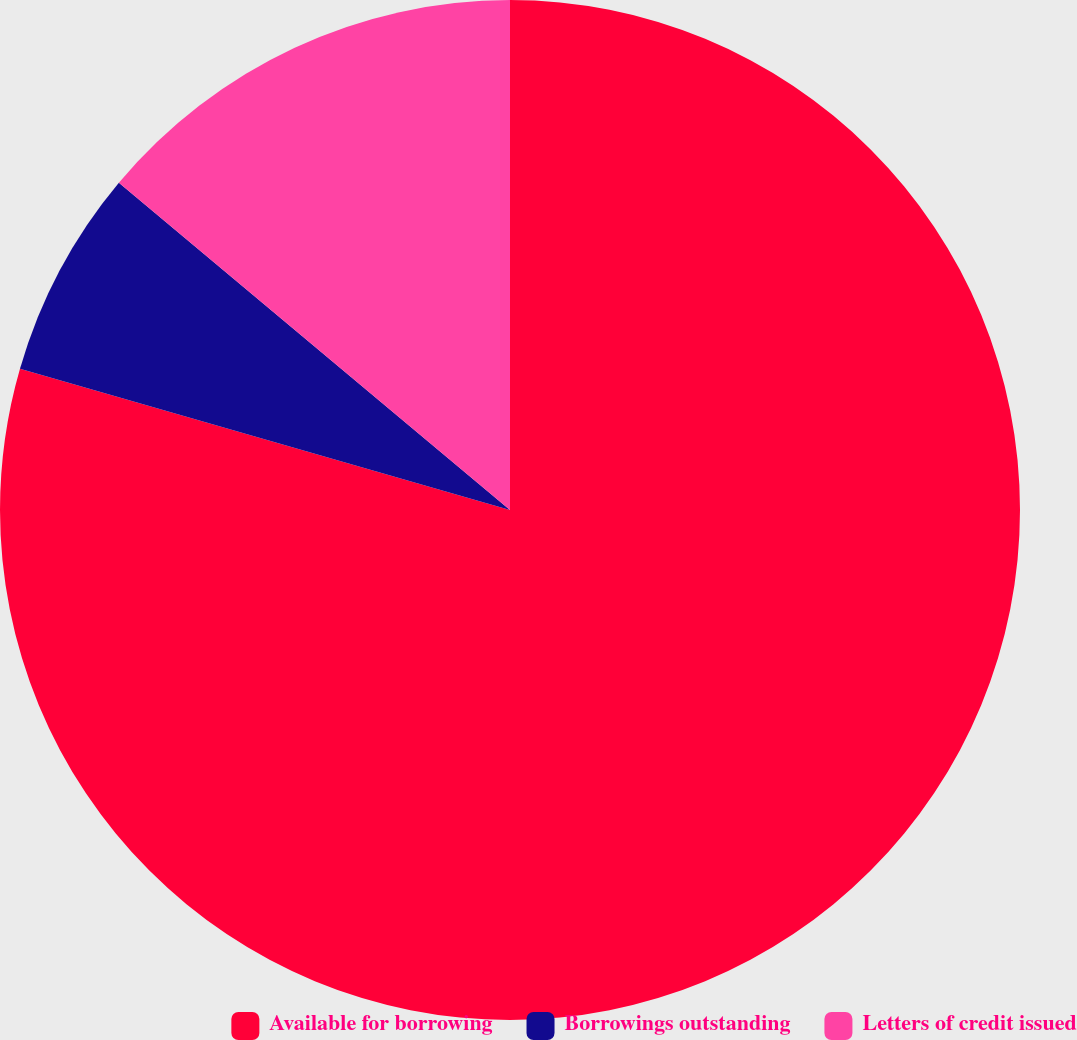Convert chart to OTSL. <chart><loc_0><loc_0><loc_500><loc_500><pie_chart><fcel>Available for borrowing<fcel>Borrowings outstanding<fcel>Letters of credit issued<nl><fcel>79.47%<fcel>6.62%<fcel>13.91%<nl></chart> 